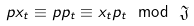Convert formula to latex. <formula><loc_0><loc_0><loc_500><loc_500>p x _ { t } \equiv p p _ { t } \equiv x _ { t } p _ { t } \ \mathrm { m o d } \ \mathfrak { J }</formula> 